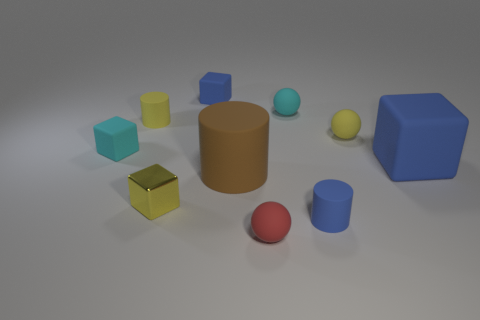Do the brown cylinder and the small red ball have the same material?
Your answer should be compact. Yes. Are there any tiny yellow things to the right of the blue object behind the blue rubber block on the right side of the tiny red ball?
Offer a terse response. Yes. Do the tiny metallic cube and the big rubber cube have the same color?
Offer a very short reply. No. Is the number of large yellow metallic spheres less than the number of tiny red spheres?
Your answer should be very brief. Yes. Is the material of the tiny sphere that is in front of the blue cylinder the same as the tiny yellow object that is to the right of the small yellow cube?
Offer a terse response. Yes. Is the number of yellow matte spheres in front of the small yellow metal object less than the number of rubber cubes?
Offer a very short reply. Yes. There is a large matte thing that is right of the yellow matte sphere; how many large brown cylinders are to the right of it?
Your answer should be very brief. 0. There is a blue object that is both behind the large brown cylinder and on the right side of the tiny red matte ball; how big is it?
Ensure brevity in your answer.  Large. Is there any other thing that is the same material as the yellow block?
Your response must be concise. No. Do the cyan ball and the blue object on the right side of the small yellow rubber ball have the same material?
Offer a terse response. Yes. 